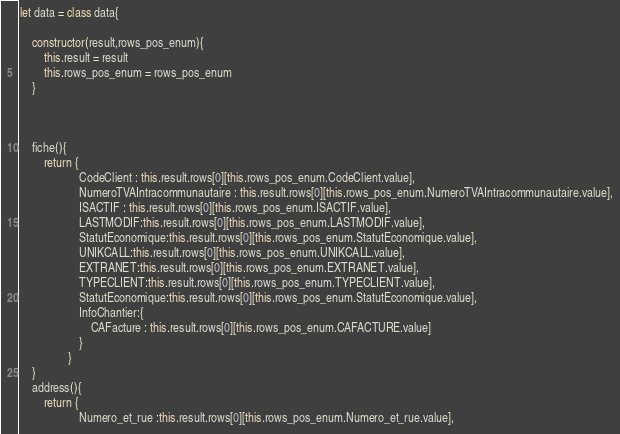<code> <loc_0><loc_0><loc_500><loc_500><_JavaScript_>
let data = class data{

    constructor(result,rows_pos_enum){
        this.result = result
        this.rows_pos_enum = rows_pos_enum
    }



    fiche(){
        return {
                    CodeClient : this.result.rows[0][this.rows_pos_enum.CodeClient.value],
                    NumeroTVAIntracommunautaire : this.result.rows[0][this.rows_pos_enum.NumeroTVAIntracommunautaire.value],
                    ISACTIF : this.result.rows[0][this.rows_pos_enum.ISACTIF.value],
                    LASTMODIF:this.result.rows[0][this.rows_pos_enum.LASTMODIF.value],
                    StatutEconomique:this.result.rows[0][this.rows_pos_enum.StatutEconomique.value],
                    UNIKCALL:this.result.rows[0][this.rows_pos_enum.UNIKCALL.value],
                    EXTRANET:this.result.rows[0][this.rows_pos_enum.EXTRANET.value],
                    TYPECLIENT:this.result.rows[0][this.rows_pos_enum.TYPECLIENT.value],
                    StatutEconomique:this.result.rows[0][this.rows_pos_enum.StatutEconomique.value],
                    InfoChantier:{
                        CAFacture : this.result.rows[0][this.rows_pos_enum.CAFACTURE.value]
                    }
                }
    } 
    address(){
        return {
                    Numero_et_rue :this.result.rows[0][this.rows_pos_enum.Numero_et_rue.value],</code> 